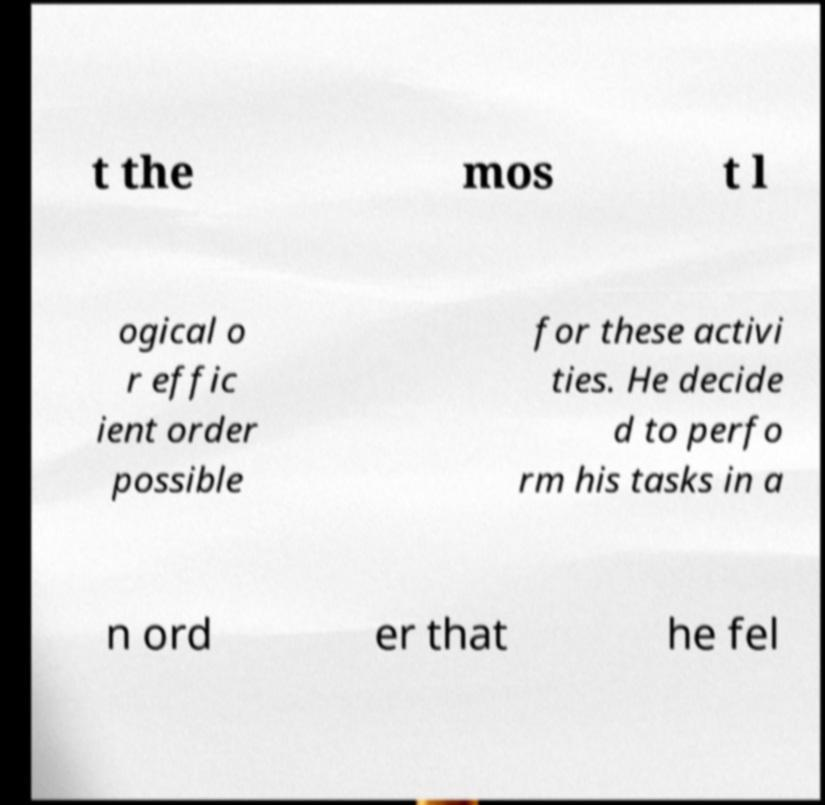There's text embedded in this image that I need extracted. Can you transcribe it verbatim? t the mos t l ogical o r effic ient order possible for these activi ties. He decide d to perfo rm his tasks in a n ord er that he fel 